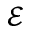Convert formula to latex. <formula><loc_0><loc_0><loc_500><loc_500>\mathcal { E }</formula> 